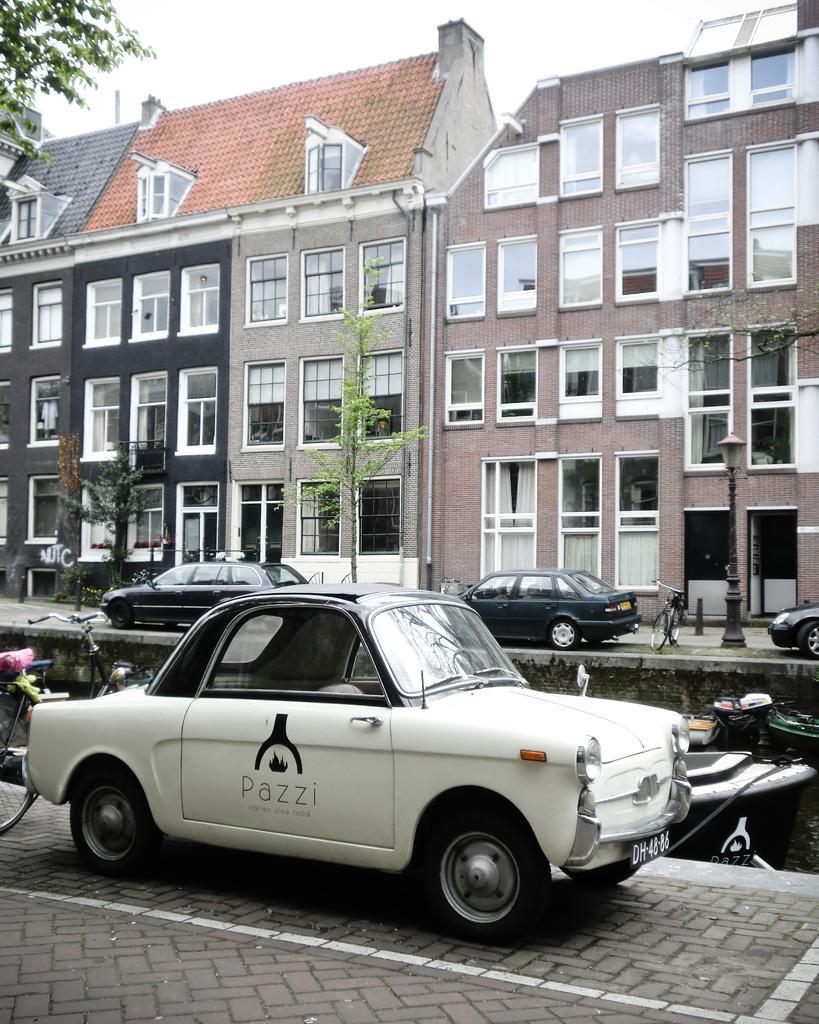In one or two sentences, can you explain what this image depicts? In this picture there are buildings and trees. In the foreground there are vehicles on the road and there is text on the vehicle and there is a streetlight. At the top there is sky. At the bottom there is a road and there are curtains behind the windows. 